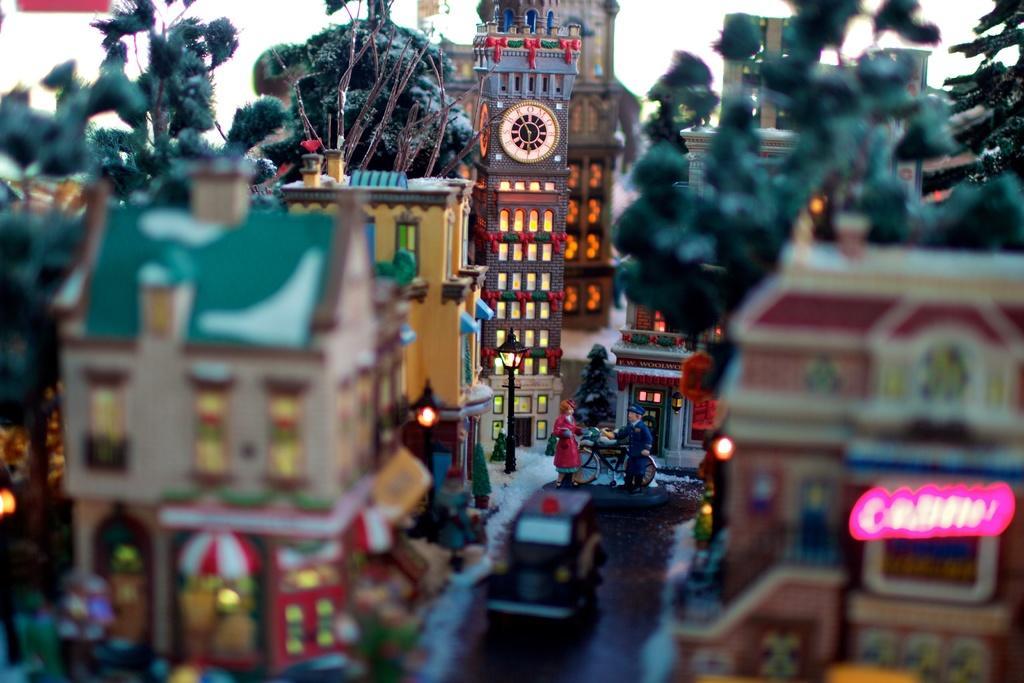Describe this image in one or two sentences. In this image we can see a group of toys in which we can see a man and a woman standing on the ground. We can also see some vehicles on the ground, a clock tower, some buildings and trees. 